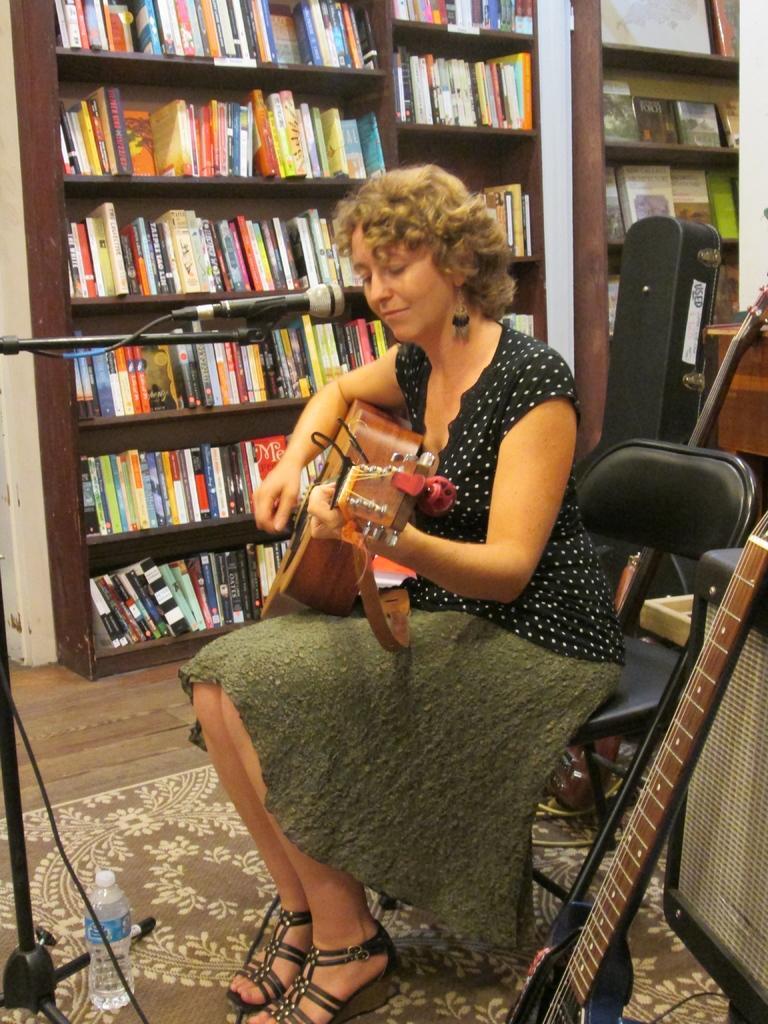Please provide a concise description of this image. A woman sitting on a chair with guitar in her hand singing in the mic which was placed on a stand. The floor has carpet on it and a bottle placed on the carpet. There is a bookshelf with lots of books in it. 